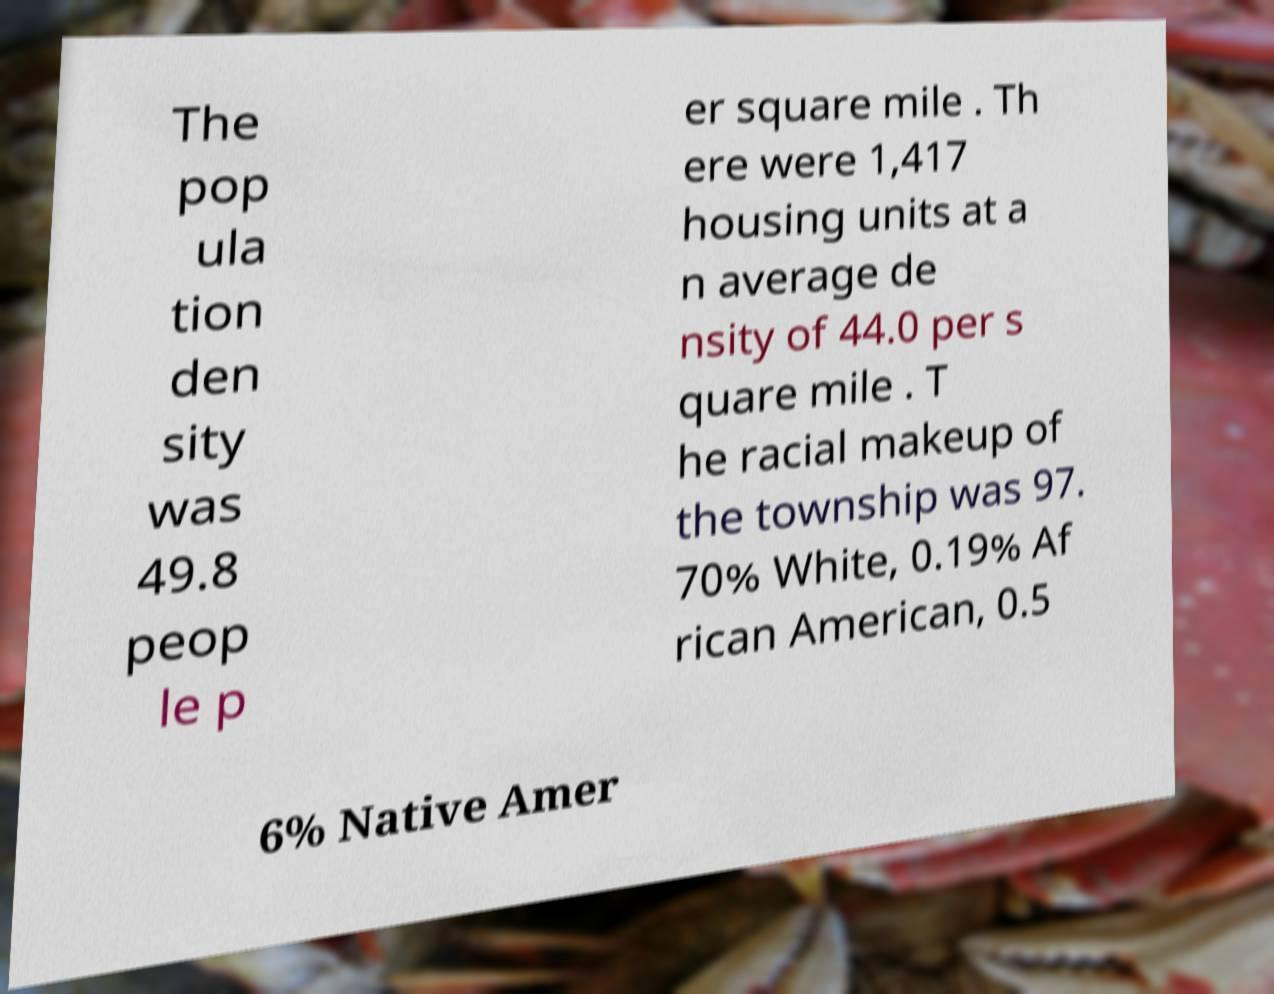Can you read and provide the text displayed in the image?This photo seems to have some interesting text. Can you extract and type it out for me? The pop ula tion den sity was 49.8 peop le p er square mile . Th ere were 1,417 housing units at a n average de nsity of 44.0 per s quare mile . T he racial makeup of the township was 97. 70% White, 0.19% Af rican American, 0.5 6% Native Amer 